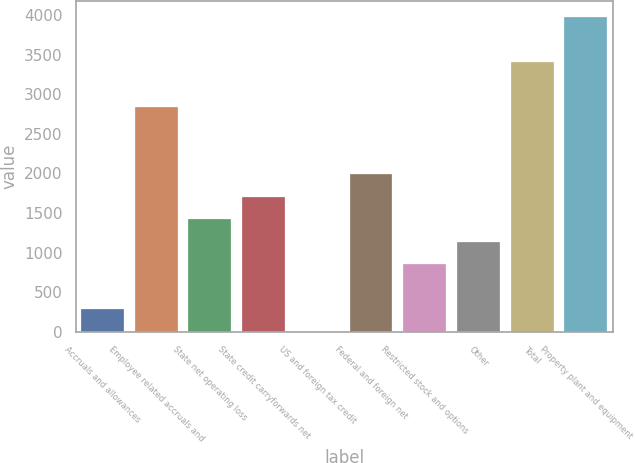Convert chart. <chart><loc_0><loc_0><loc_500><loc_500><bar_chart><fcel>Accruals and allowances<fcel>Employee related accruals and<fcel>State net operating loss<fcel>State credit carryforwards net<fcel>US and foreign tax credit<fcel>Federal and foreign net<fcel>Restricted stock and options<fcel>Other<fcel>Total<fcel>Property plant and equipment<nl><fcel>285.08<fcel>2844.5<fcel>1422.6<fcel>1706.98<fcel>0.7<fcel>1991.36<fcel>853.84<fcel>1138.22<fcel>3413.26<fcel>3982.02<nl></chart> 